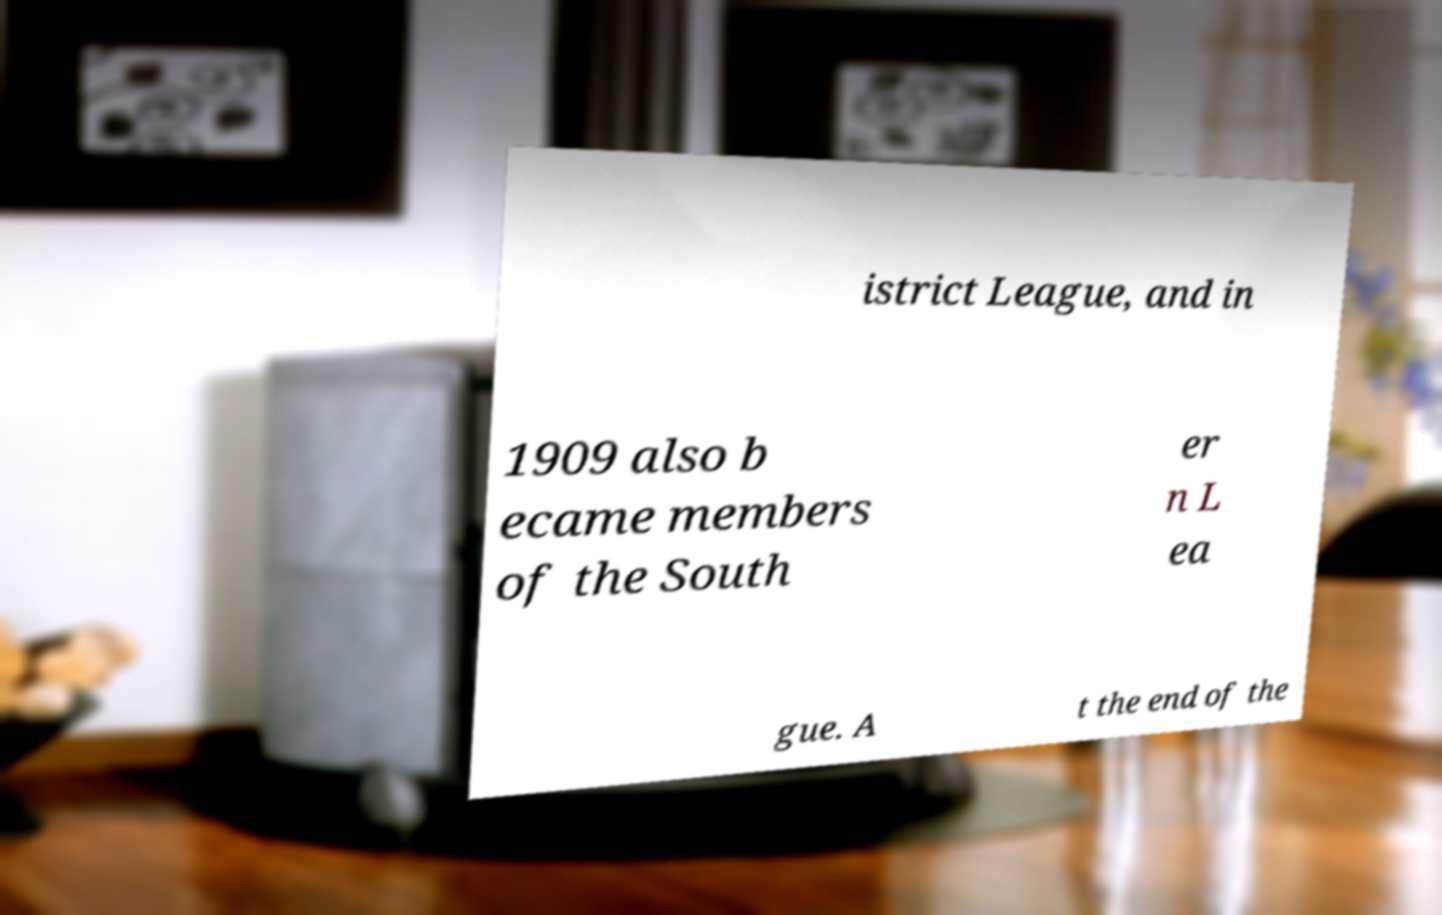Can you accurately transcribe the text from the provided image for me? istrict League, and in 1909 also b ecame members of the South er n L ea gue. A t the end of the 